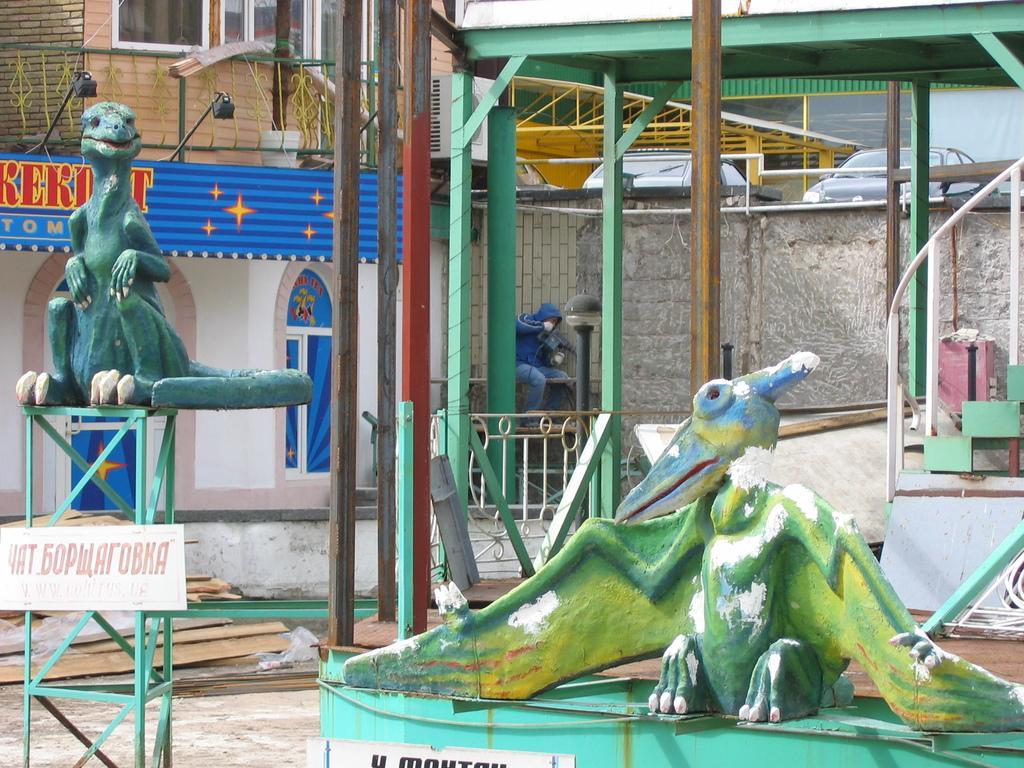Please provide a concise description of this image. In this image there is a man sitting, he is holding an object, there are windows towards the top of the image, there is a wall, there are lights, there are cars, there is a board, there is text on the board, there are objects towards the right of the image, there are objects on the ground, there are objects that resemble animals, there is a board towards the bottom of the image, there is an object towards the bottom of the image. 